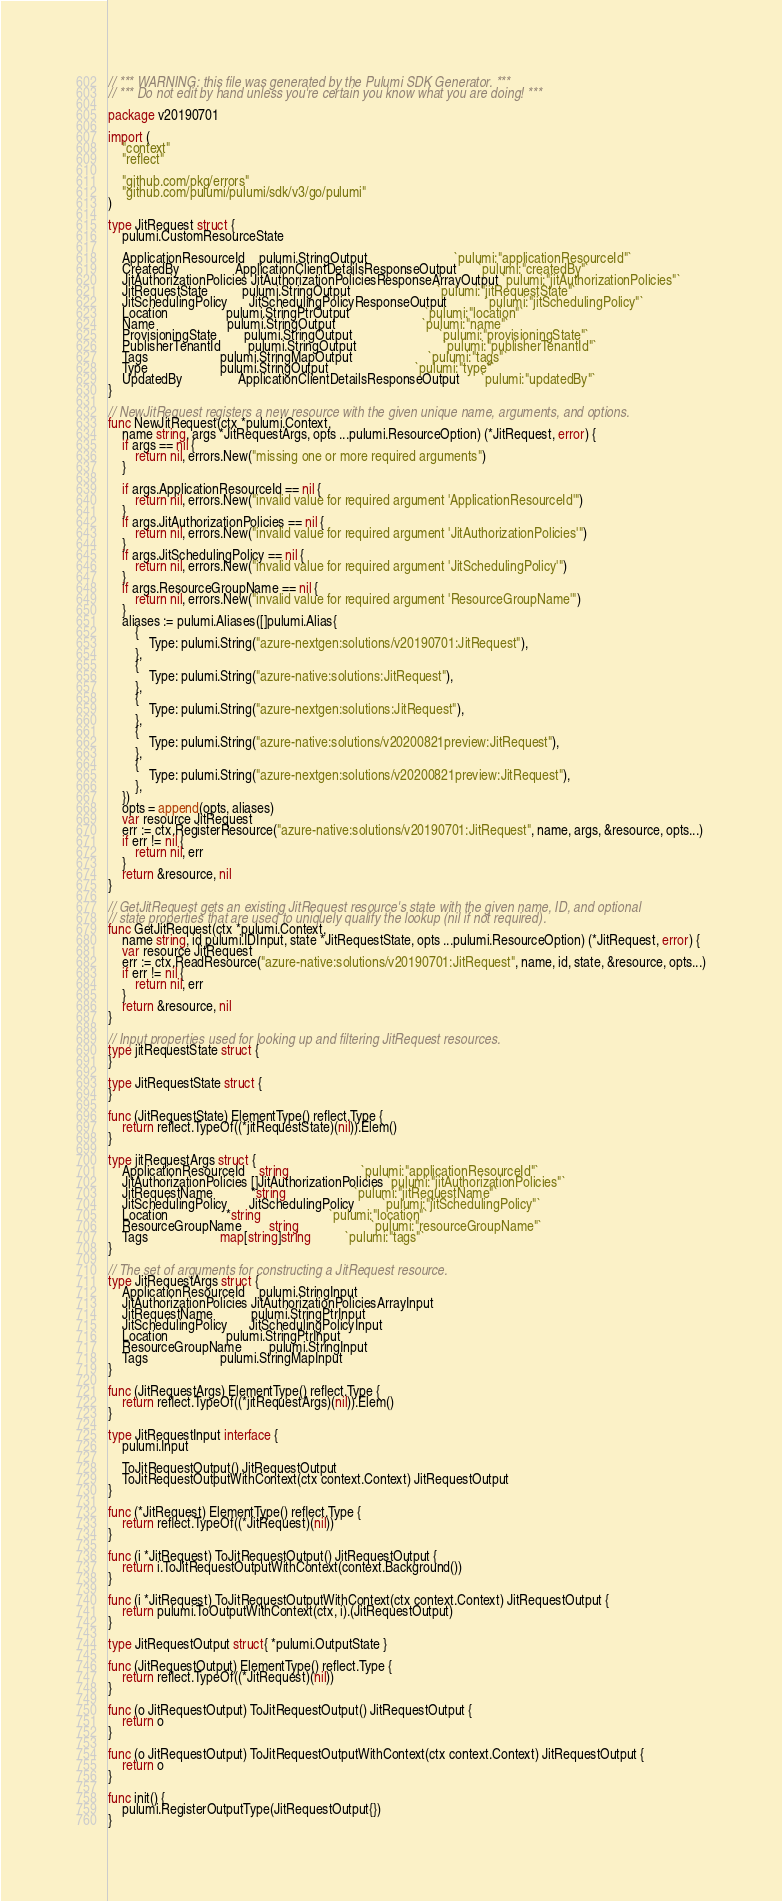<code> <loc_0><loc_0><loc_500><loc_500><_Go_>// *** WARNING: this file was generated by the Pulumi SDK Generator. ***
// *** Do not edit by hand unless you're certain you know what you are doing! ***

package v20190701

import (
	"context"
	"reflect"

	"github.com/pkg/errors"
	"github.com/pulumi/pulumi/sdk/v3/go/pulumi"
)

type JitRequest struct {
	pulumi.CustomResourceState

	ApplicationResourceId    pulumi.StringOutput                         `pulumi:"applicationResourceId"`
	CreatedBy                ApplicationClientDetailsResponseOutput      `pulumi:"createdBy"`
	JitAuthorizationPolicies JitAuthorizationPoliciesResponseArrayOutput `pulumi:"jitAuthorizationPolicies"`
	JitRequestState          pulumi.StringOutput                         `pulumi:"jitRequestState"`
	JitSchedulingPolicy      JitSchedulingPolicyResponseOutput           `pulumi:"jitSchedulingPolicy"`
	Location                 pulumi.StringPtrOutput                      `pulumi:"location"`
	Name                     pulumi.StringOutput                         `pulumi:"name"`
	ProvisioningState        pulumi.StringOutput                         `pulumi:"provisioningState"`
	PublisherTenantId        pulumi.StringOutput                         `pulumi:"publisherTenantId"`
	Tags                     pulumi.StringMapOutput                      `pulumi:"tags"`
	Type                     pulumi.StringOutput                         `pulumi:"type"`
	UpdatedBy                ApplicationClientDetailsResponseOutput      `pulumi:"updatedBy"`
}

// NewJitRequest registers a new resource with the given unique name, arguments, and options.
func NewJitRequest(ctx *pulumi.Context,
	name string, args *JitRequestArgs, opts ...pulumi.ResourceOption) (*JitRequest, error) {
	if args == nil {
		return nil, errors.New("missing one or more required arguments")
	}

	if args.ApplicationResourceId == nil {
		return nil, errors.New("invalid value for required argument 'ApplicationResourceId'")
	}
	if args.JitAuthorizationPolicies == nil {
		return nil, errors.New("invalid value for required argument 'JitAuthorizationPolicies'")
	}
	if args.JitSchedulingPolicy == nil {
		return nil, errors.New("invalid value for required argument 'JitSchedulingPolicy'")
	}
	if args.ResourceGroupName == nil {
		return nil, errors.New("invalid value for required argument 'ResourceGroupName'")
	}
	aliases := pulumi.Aliases([]pulumi.Alias{
		{
			Type: pulumi.String("azure-nextgen:solutions/v20190701:JitRequest"),
		},
		{
			Type: pulumi.String("azure-native:solutions:JitRequest"),
		},
		{
			Type: pulumi.String("azure-nextgen:solutions:JitRequest"),
		},
		{
			Type: pulumi.String("azure-native:solutions/v20200821preview:JitRequest"),
		},
		{
			Type: pulumi.String("azure-nextgen:solutions/v20200821preview:JitRequest"),
		},
	})
	opts = append(opts, aliases)
	var resource JitRequest
	err := ctx.RegisterResource("azure-native:solutions/v20190701:JitRequest", name, args, &resource, opts...)
	if err != nil {
		return nil, err
	}
	return &resource, nil
}

// GetJitRequest gets an existing JitRequest resource's state with the given name, ID, and optional
// state properties that are used to uniquely qualify the lookup (nil if not required).
func GetJitRequest(ctx *pulumi.Context,
	name string, id pulumi.IDInput, state *JitRequestState, opts ...pulumi.ResourceOption) (*JitRequest, error) {
	var resource JitRequest
	err := ctx.ReadResource("azure-native:solutions/v20190701:JitRequest", name, id, state, &resource, opts...)
	if err != nil {
		return nil, err
	}
	return &resource, nil
}

// Input properties used for looking up and filtering JitRequest resources.
type jitRequestState struct {
}

type JitRequestState struct {
}

func (JitRequestState) ElementType() reflect.Type {
	return reflect.TypeOf((*jitRequestState)(nil)).Elem()
}

type jitRequestArgs struct {
	ApplicationResourceId    string                     `pulumi:"applicationResourceId"`
	JitAuthorizationPolicies []JitAuthorizationPolicies `pulumi:"jitAuthorizationPolicies"`
	JitRequestName           *string                    `pulumi:"jitRequestName"`
	JitSchedulingPolicy      JitSchedulingPolicy        `pulumi:"jitSchedulingPolicy"`
	Location                 *string                    `pulumi:"location"`
	ResourceGroupName        string                     `pulumi:"resourceGroupName"`
	Tags                     map[string]string          `pulumi:"tags"`
}

// The set of arguments for constructing a JitRequest resource.
type JitRequestArgs struct {
	ApplicationResourceId    pulumi.StringInput
	JitAuthorizationPolicies JitAuthorizationPoliciesArrayInput
	JitRequestName           pulumi.StringPtrInput
	JitSchedulingPolicy      JitSchedulingPolicyInput
	Location                 pulumi.StringPtrInput
	ResourceGroupName        pulumi.StringInput
	Tags                     pulumi.StringMapInput
}

func (JitRequestArgs) ElementType() reflect.Type {
	return reflect.TypeOf((*jitRequestArgs)(nil)).Elem()
}

type JitRequestInput interface {
	pulumi.Input

	ToJitRequestOutput() JitRequestOutput
	ToJitRequestOutputWithContext(ctx context.Context) JitRequestOutput
}

func (*JitRequest) ElementType() reflect.Type {
	return reflect.TypeOf((*JitRequest)(nil))
}

func (i *JitRequest) ToJitRequestOutput() JitRequestOutput {
	return i.ToJitRequestOutputWithContext(context.Background())
}

func (i *JitRequest) ToJitRequestOutputWithContext(ctx context.Context) JitRequestOutput {
	return pulumi.ToOutputWithContext(ctx, i).(JitRequestOutput)
}

type JitRequestOutput struct{ *pulumi.OutputState }

func (JitRequestOutput) ElementType() reflect.Type {
	return reflect.TypeOf((*JitRequest)(nil))
}

func (o JitRequestOutput) ToJitRequestOutput() JitRequestOutput {
	return o
}

func (o JitRequestOutput) ToJitRequestOutputWithContext(ctx context.Context) JitRequestOutput {
	return o
}

func init() {
	pulumi.RegisterOutputType(JitRequestOutput{})
}
</code> 